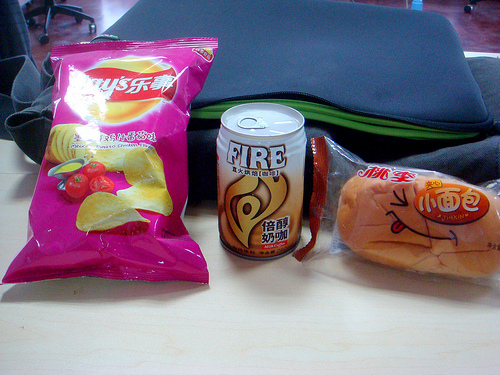<image>
Is there a chips behind the soda? No. The chips is not behind the soda. From this viewpoint, the chips appears to be positioned elsewhere in the scene. Where is the chips in relation to the bag? Is it in the bag? Yes. The chips is contained within or inside the bag, showing a containment relationship. Is there a soda next to the chips? Yes. The soda is positioned adjacent to the chips, located nearby in the same general area. Is there a chips next to the can? Yes. The chips is positioned adjacent to the can, located nearby in the same general area. 